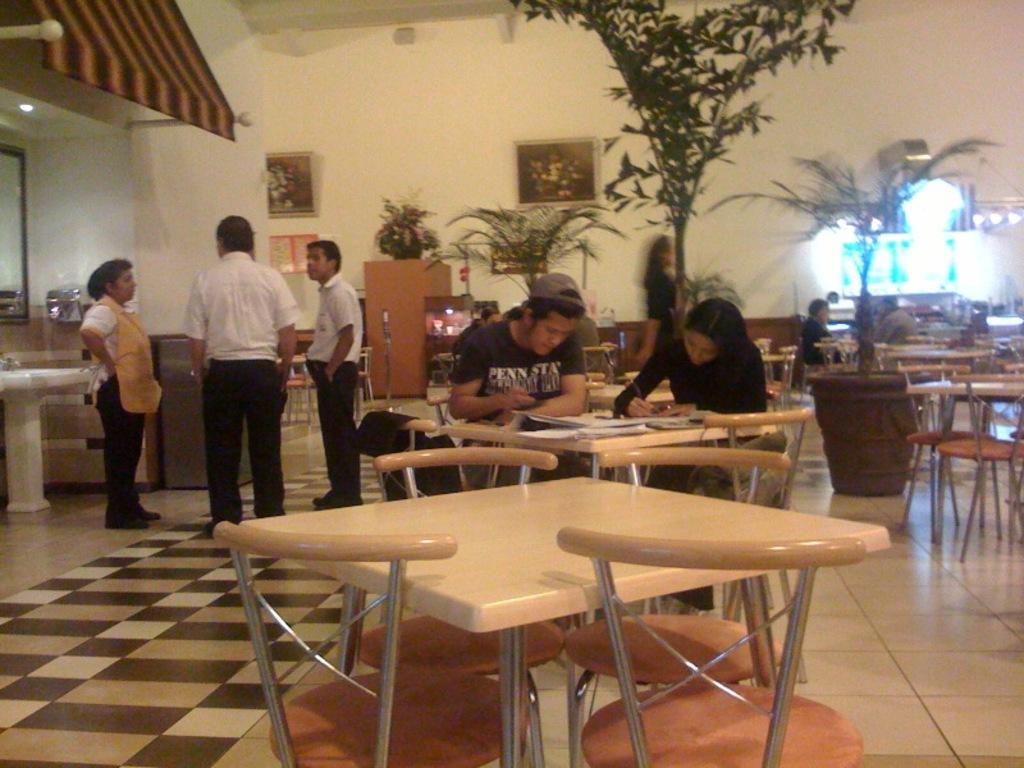Can you describe this image briefly? In this current picture, there are two members sitting in front of a table in their chairs. There are some books on their table. There are three members standing here and talking. In the background there is a woman walking and we can observe some lights and trees here. There is a photograph attached to the wall in the background. 